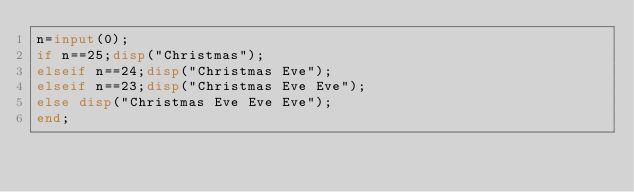<code> <loc_0><loc_0><loc_500><loc_500><_Octave_>n=input(0);
if n==25;disp("Christmas");
elseif n==24;disp("Christmas Eve");
elseif n==23;disp("Christmas Eve Eve");
else disp("Christmas Eve Eve Eve");
end;</code> 